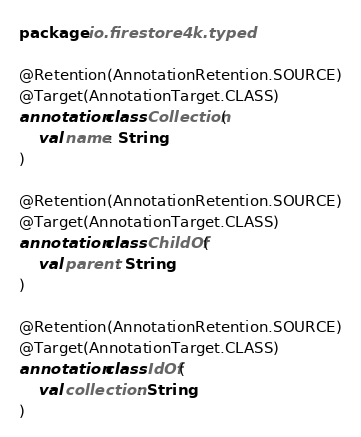Convert code to text. <code><loc_0><loc_0><loc_500><loc_500><_Kotlin_>package io.firestore4k.typed

@Retention(AnnotationRetention.SOURCE)
@Target(AnnotationTarget.CLASS)
annotation class Collection(
    val name: String
)

@Retention(AnnotationRetention.SOURCE)
@Target(AnnotationTarget.CLASS)
annotation class ChildOf(
    val parent: String
)

@Retention(AnnotationRetention.SOURCE)
@Target(AnnotationTarget.CLASS)
annotation class IdOf(
    val collection: String
)</code> 